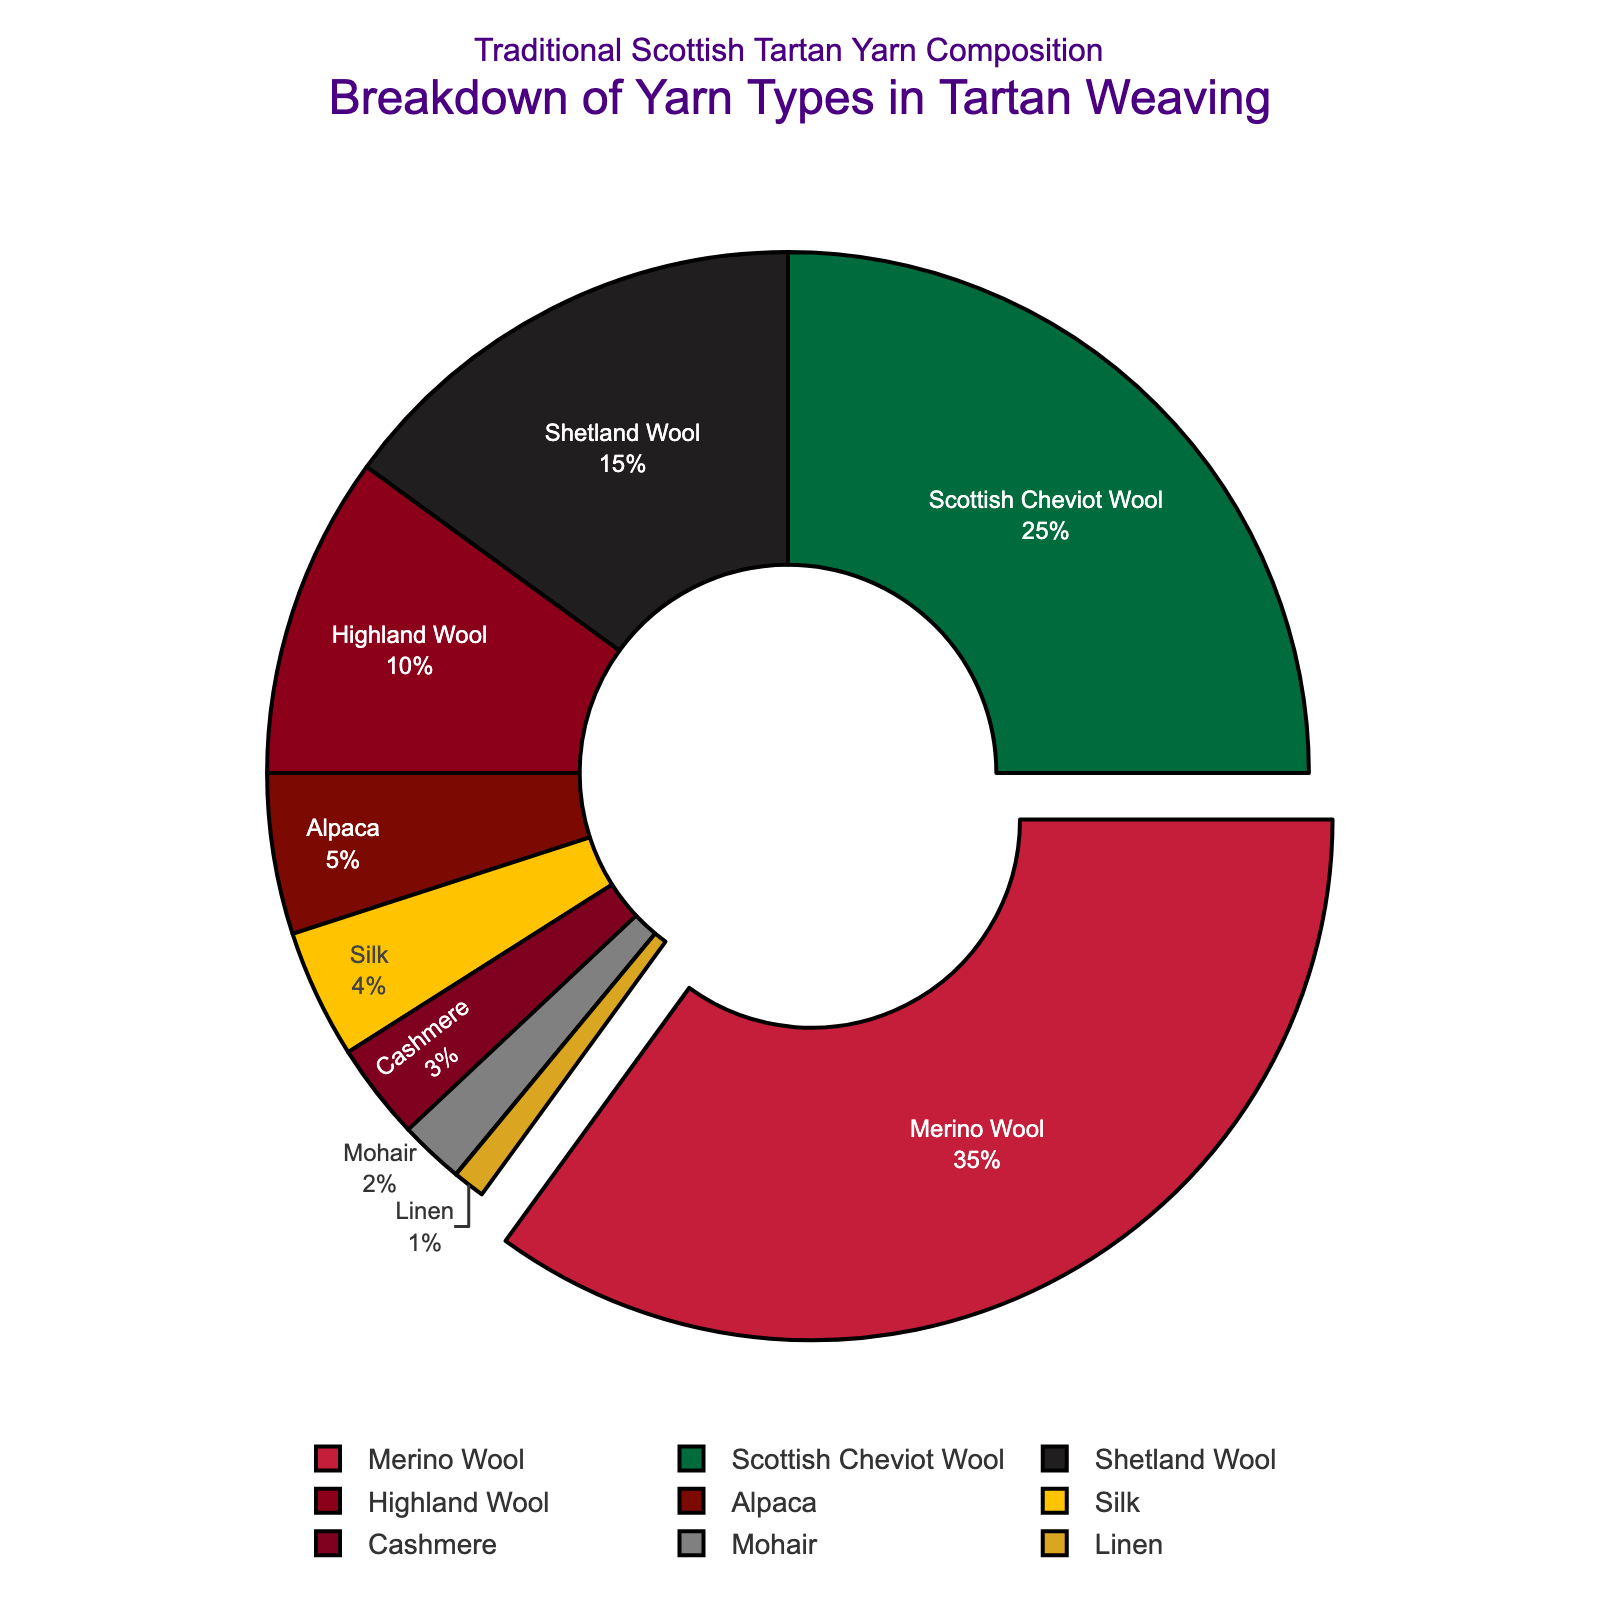what percentage of yarns are made from animal fibers? Add together the percentages of Merino Wool, Scottish Cheviot Wool, Shetland Wool, Highland Wool, Alpaca, Silk, Cashmere, and Mohair: 35 + 25 + 15 + 10 + 5 + 4 + 3 + 2 = 99
Answer: 99 Which yarn type is used the least in tartan weaving? The yarn type with the smallest percentage on the chart is Linen, at 1%
Answer: Linen What is the combined percentage of Merino Wool and Scottish Cheviot Wool? Add the percentages of Merino Wool and Scottish Cheviot Wool: 35 + 25 = 60
Answer: 60 How much more Merino Wool is used compared to Alpaca? Subtract the percentage of Alpaca from Merino Wool: 35 - 5 = 30
Answer: 30 Which yarn type is visually represented with the largest segment in the chart? The visually largest segment belongs to Merino Wool, which has the highest percentage at 35%
Answer: Merino Wool Does Silk or Cashmere have a higher percentage? Silk has a higher percentage (4%) compared to Cashmere (3%)
Answer: Silk What percentage of the yarns have a percentage lower than 10%? Sum the percentages of Alpaca, Silk, Cashmere, Mohair, and Linen: 5 + 4 + 3 + 2 + 1 = 15
Answer: 15 If you combine Highland Wool and Shetland Wool, what is the total percentage? Add the percentages of Highland Wool and Shetland Wool: 10 + 15 = 25
Answer: 25 Which categories together make up more than half of the yarn types used? Sum the percentages of Merino Wool, Scottish Cheviot Wool, Shetland Wool: 35 + 25 + 15 = 75, which is more than 50%
Answer: Merino Wool, Scottish Cheviot Wool, Shetland Wool What percentage difference is there between the yarn types with the largest and smallest segments? Subtract the percentage of Linen from Merino Wool: 35 - 1 = 34
Answer: 34 